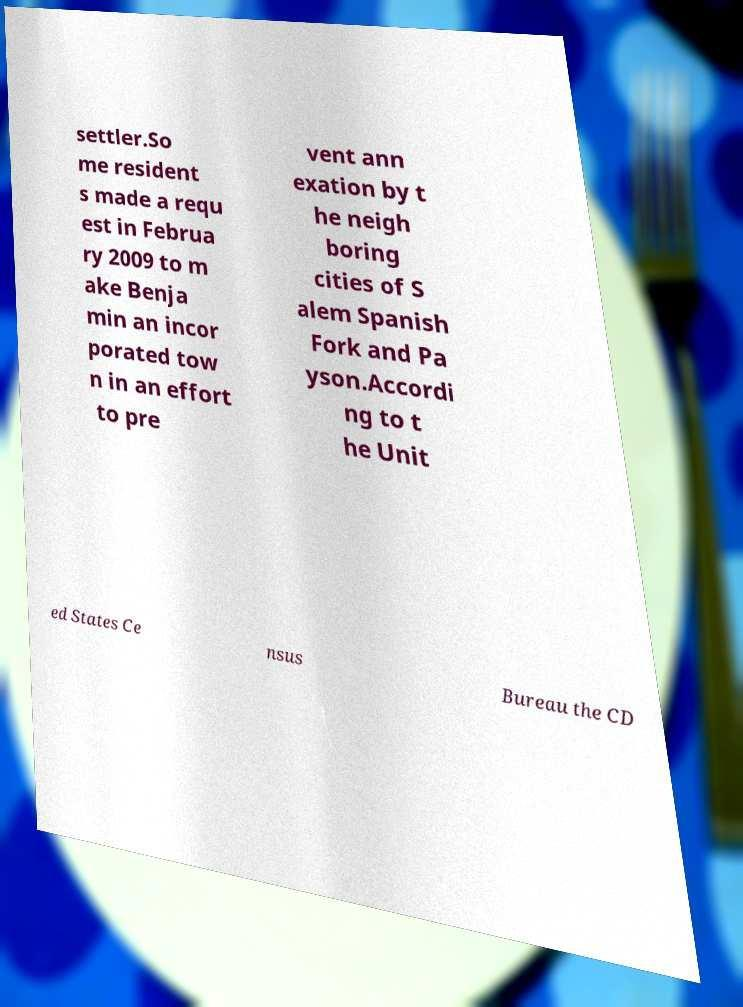Could you assist in decoding the text presented in this image and type it out clearly? settler.So me resident s made a requ est in Februa ry 2009 to m ake Benja min an incor porated tow n in an effort to pre vent ann exation by t he neigh boring cities of S alem Spanish Fork and Pa yson.Accordi ng to t he Unit ed States Ce nsus Bureau the CD 